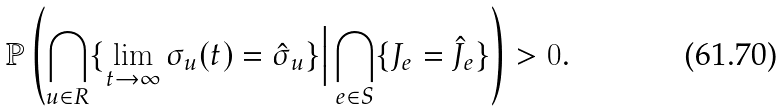<formula> <loc_0><loc_0><loc_500><loc_500>\mathbb { P } \left ( \bigcap _ { u \in R } \{ \lim _ { t \to \infty } \sigma _ { u } ( t ) = \hat { \sigma } _ { u } \} \Big | \bigcap _ { e \in S } \{ J _ { e } = \hat { J } _ { e } \} \right ) > 0 .</formula> 